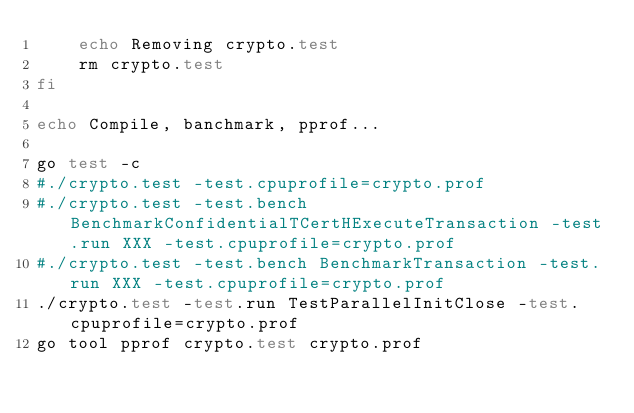<code> <loc_0><loc_0><loc_500><loc_500><_Bash_>    echo Removing crypto.test
    rm crypto.test
fi

echo Compile, banchmark, pprof...

go test -c
#./crypto.test -test.cpuprofile=crypto.prof
#./crypto.test -test.bench BenchmarkConfidentialTCertHExecuteTransaction -test.run XXX -test.cpuprofile=crypto.prof
#./crypto.test -test.bench BenchmarkTransaction -test.run XXX -test.cpuprofile=crypto.prof
./crypto.test -test.run TestParallelInitClose -test.cpuprofile=crypto.prof
go tool pprof crypto.test crypto.prof</code> 